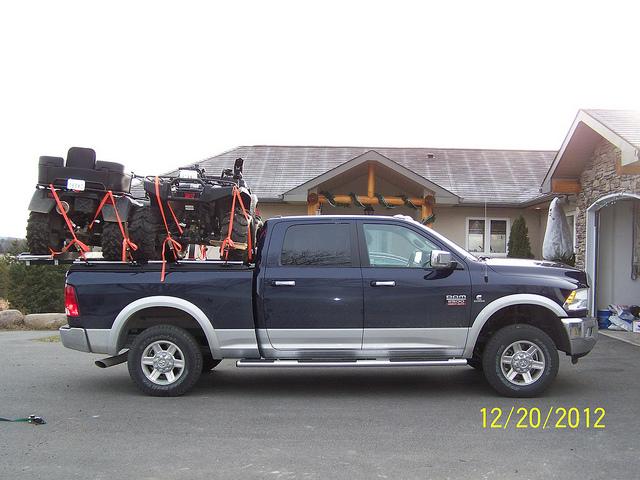Is this a wise decision or an accident waiting to happen?
Concise answer only. Accident waiting to happen. How many vehicles are shown?
Concise answer only. 3. What color is the pickup truck?
Quick response, please. Blue. What color is the truck?
Keep it brief. Black. How old is the truck?
Keep it brief. 5 years. What is the main color of the truck?
Write a very short answer. Black. Do you think this is a Ford or Chevy?
Quick response, please. Ford. 